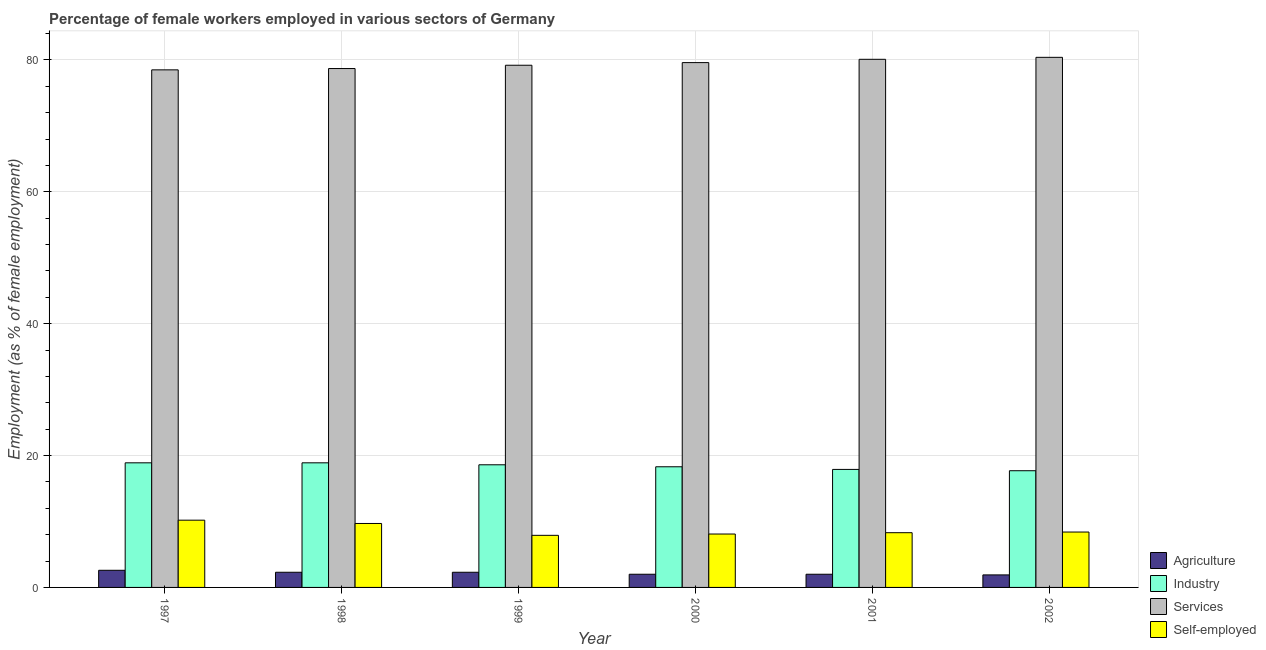How many groups of bars are there?
Provide a short and direct response. 6. Are the number of bars per tick equal to the number of legend labels?
Keep it short and to the point. Yes. Are the number of bars on each tick of the X-axis equal?
Make the answer very short. Yes. How many bars are there on the 1st tick from the right?
Ensure brevity in your answer.  4. What is the percentage of female workers in industry in 1999?
Provide a short and direct response. 18.6. Across all years, what is the maximum percentage of self employed female workers?
Provide a succinct answer. 10.2. Across all years, what is the minimum percentage of female workers in services?
Give a very brief answer. 78.5. In which year was the percentage of female workers in industry minimum?
Your answer should be very brief. 2002. What is the total percentage of female workers in industry in the graph?
Offer a terse response. 110.3. What is the difference between the percentage of self employed female workers in 1998 and that in 1999?
Provide a short and direct response. 1.8. What is the difference between the percentage of self employed female workers in 2002 and the percentage of female workers in industry in 1998?
Your answer should be compact. -1.3. What is the average percentage of female workers in industry per year?
Give a very brief answer. 18.38. What is the ratio of the percentage of female workers in agriculture in 1997 to that in 1998?
Provide a short and direct response. 1.13. Is the percentage of female workers in services in 1998 less than that in 1999?
Make the answer very short. Yes. What is the difference between the highest and the second highest percentage of female workers in agriculture?
Your answer should be compact. 0.3. What is the difference between the highest and the lowest percentage of female workers in services?
Offer a terse response. 1.9. Is the sum of the percentage of female workers in agriculture in 2000 and 2001 greater than the maximum percentage of female workers in services across all years?
Offer a terse response. Yes. Is it the case that in every year, the sum of the percentage of female workers in industry and percentage of female workers in agriculture is greater than the sum of percentage of self employed female workers and percentage of female workers in services?
Your answer should be very brief. No. What does the 4th bar from the left in 2002 represents?
Your answer should be compact. Self-employed. What does the 3rd bar from the right in 1997 represents?
Your answer should be compact. Industry. Is it the case that in every year, the sum of the percentage of female workers in agriculture and percentage of female workers in industry is greater than the percentage of female workers in services?
Offer a very short reply. No. How many bars are there?
Your answer should be very brief. 24. How many years are there in the graph?
Offer a terse response. 6. What is the difference between two consecutive major ticks on the Y-axis?
Keep it short and to the point. 20. Are the values on the major ticks of Y-axis written in scientific E-notation?
Make the answer very short. No. Where does the legend appear in the graph?
Provide a short and direct response. Bottom right. What is the title of the graph?
Your response must be concise. Percentage of female workers employed in various sectors of Germany. What is the label or title of the X-axis?
Make the answer very short. Year. What is the label or title of the Y-axis?
Ensure brevity in your answer.  Employment (as % of female employment). What is the Employment (as % of female employment) in Agriculture in 1997?
Keep it short and to the point. 2.6. What is the Employment (as % of female employment) of Industry in 1997?
Your answer should be very brief. 18.9. What is the Employment (as % of female employment) of Services in 1997?
Offer a terse response. 78.5. What is the Employment (as % of female employment) in Self-employed in 1997?
Your response must be concise. 10.2. What is the Employment (as % of female employment) in Agriculture in 1998?
Your answer should be compact. 2.3. What is the Employment (as % of female employment) in Industry in 1998?
Provide a succinct answer. 18.9. What is the Employment (as % of female employment) of Services in 1998?
Keep it short and to the point. 78.7. What is the Employment (as % of female employment) in Self-employed in 1998?
Keep it short and to the point. 9.7. What is the Employment (as % of female employment) of Agriculture in 1999?
Provide a short and direct response. 2.3. What is the Employment (as % of female employment) of Industry in 1999?
Provide a succinct answer. 18.6. What is the Employment (as % of female employment) in Services in 1999?
Provide a short and direct response. 79.2. What is the Employment (as % of female employment) in Self-employed in 1999?
Your answer should be compact. 7.9. What is the Employment (as % of female employment) in Industry in 2000?
Provide a succinct answer. 18.3. What is the Employment (as % of female employment) of Services in 2000?
Provide a succinct answer. 79.6. What is the Employment (as % of female employment) in Self-employed in 2000?
Offer a very short reply. 8.1. What is the Employment (as % of female employment) in Industry in 2001?
Offer a terse response. 17.9. What is the Employment (as % of female employment) in Services in 2001?
Provide a short and direct response. 80.1. What is the Employment (as % of female employment) of Self-employed in 2001?
Your answer should be very brief. 8.3. What is the Employment (as % of female employment) of Agriculture in 2002?
Offer a very short reply. 1.9. What is the Employment (as % of female employment) in Industry in 2002?
Provide a succinct answer. 17.7. What is the Employment (as % of female employment) of Services in 2002?
Provide a succinct answer. 80.4. What is the Employment (as % of female employment) in Self-employed in 2002?
Give a very brief answer. 8.4. Across all years, what is the maximum Employment (as % of female employment) in Agriculture?
Offer a terse response. 2.6. Across all years, what is the maximum Employment (as % of female employment) of Industry?
Ensure brevity in your answer.  18.9. Across all years, what is the maximum Employment (as % of female employment) of Services?
Your answer should be compact. 80.4. Across all years, what is the maximum Employment (as % of female employment) in Self-employed?
Give a very brief answer. 10.2. Across all years, what is the minimum Employment (as % of female employment) in Agriculture?
Your answer should be compact. 1.9. Across all years, what is the minimum Employment (as % of female employment) in Industry?
Keep it short and to the point. 17.7. Across all years, what is the minimum Employment (as % of female employment) of Services?
Offer a very short reply. 78.5. Across all years, what is the minimum Employment (as % of female employment) in Self-employed?
Provide a succinct answer. 7.9. What is the total Employment (as % of female employment) of Industry in the graph?
Your answer should be very brief. 110.3. What is the total Employment (as % of female employment) of Services in the graph?
Offer a very short reply. 476.5. What is the total Employment (as % of female employment) in Self-employed in the graph?
Your response must be concise. 52.6. What is the difference between the Employment (as % of female employment) of Industry in 1997 and that in 1998?
Keep it short and to the point. 0. What is the difference between the Employment (as % of female employment) of Self-employed in 1997 and that in 1998?
Give a very brief answer. 0.5. What is the difference between the Employment (as % of female employment) of Agriculture in 1997 and that in 1999?
Keep it short and to the point. 0.3. What is the difference between the Employment (as % of female employment) of Industry in 1997 and that in 1999?
Your answer should be compact. 0.3. What is the difference between the Employment (as % of female employment) in Services in 1997 and that in 1999?
Your answer should be compact. -0.7. What is the difference between the Employment (as % of female employment) in Self-employed in 1997 and that in 1999?
Make the answer very short. 2.3. What is the difference between the Employment (as % of female employment) in Agriculture in 1997 and that in 2000?
Your answer should be very brief. 0.6. What is the difference between the Employment (as % of female employment) in Industry in 1997 and that in 2000?
Provide a short and direct response. 0.6. What is the difference between the Employment (as % of female employment) in Services in 1997 and that in 2000?
Provide a succinct answer. -1.1. What is the difference between the Employment (as % of female employment) of Industry in 1997 and that in 2001?
Give a very brief answer. 1. What is the difference between the Employment (as % of female employment) of Self-employed in 1997 and that in 2001?
Make the answer very short. 1.9. What is the difference between the Employment (as % of female employment) in Industry in 1997 and that in 2002?
Give a very brief answer. 1.2. What is the difference between the Employment (as % of female employment) in Services in 1998 and that in 1999?
Provide a short and direct response. -0.5. What is the difference between the Employment (as % of female employment) in Self-employed in 1998 and that in 1999?
Your answer should be compact. 1.8. What is the difference between the Employment (as % of female employment) in Industry in 1998 and that in 2000?
Make the answer very short. 0.6. What is the difference between the Employment (as % of female employment) of Services in 1998 and that in 2000?
Your response must be concise. -0.9. What is the difference between the Employment (as % of female employment) in Self-employed in 1998 and that in 2000?
Your answer should be compact. 1.6. What is the difference between the Employment (as % of female employment) in Agriculture in 1998 and that in 2002?
Your answer should be very brief. 0.4. What is the difference between the Employment (as % of female employment) in Services in 1998 and that in 2002?
Make the answer very short. -1.7. What is the difference between the Employment (as % of female employment) in Self-employed in 1998 and that in 2002?
Your answer should be compact. 1.3. What is the difference between the Employment (as % of female employment) in Agriculture in 1999 and that in 2000?
Your answer should be very brief. 0.3. What is the difference between the Employment (as % of female employment) in Industry in 1999 and that in 2000?
Keep it short and to the point. 0.3. What is the difference between the Employment (as % of female employment) of Self-employed in 1999 and that in 2000?
Keep it short and to the point. -0.2. What is the difference between the Employment (as % of female employment) in Agriculture in 1999 and that in 2001?
Provide a succinct answer. 0.3. What is the difference between the Employment (as % of female employment) of Industry in 1999 and that in 2001?
Your answer should be compact. 0.7. What is the difference between the Employment (as % of female employment) of Self-employed in 1999 and that in 2001?
Ensure brevity in your answer.  -0.4. What is the difference between the Employment (as % of female employment) in Agriculture in 1999 and that in 2002?
Your answer should be very brief. 0.4. What is the difference between the Employment (as % of female employment) in Services in 1999 and that in 2002?
Provide a succinct answer. -1.2. What is the difference between the Employment (as % of female employment) in Self-employed in 1999 and that in 2002?
Provide a short and direct response. -0.5. What is the difference between the Employment (as % of female employment) in Services in 2000 and that in 2001?
Your response must be concise. -0.5. What is the difference between the Employment (as % of female employment) in Self-employed in 2000 and that in 2001?
Your response must be concise. -0.2. What is the difference between the Employment (as % of female employment) in Industry in 2000 and that in 2002?
Offer a terse response. 0.6. What is the difference between the Employment (as % of female employment) of Services in 2000 and that in 2002?
Offer a very short reply. -0.8. What is the difference between the Employment (as % of female employment) of Agriculture in 2001 and that in 2002?
Your answer should be compact. 0.1. What is the difference between the Employment (as % of female employment) in Industry in 2001 and that in 2002?
Your response must be concise. 0.2. What is the difference between the Employment (as % of female employment) of Services in 2001 and that in 2002?
Your response must be concise. -0.3. What is the difference between the Employment (as % of female employment) in Self-employed in 2001 and that in 2002?
Provide a short and direct response. -0.1. What is the difference between the Employment (as % of female employment) in Agriculture in 1997 and the Employment (as % of female employment) in Industry in 1998?
Provide a succinct answer. -16.3. What is the difference between the Employment (as % of female employment) in Agriculture in 1997 and the Employment (as % of female employment) in Services in 1998?
Offer a terse response. -76.1. What is the difference between the Employment (as % of female employment) in Agriculture in 1997 and the Employment (as % of female employment) in Self-employed in 1998?
Your answer should be compact. -7.1. What is the difference between the Employment (as % of female employment) in Industry in 1997 and the Employment (as % of female employment) in Services in 1998?
Provide a short and direct response. -59.8. What is the difference between the Employment (as % of female employment) of Industry in 1997 and the Employment (as % of female employment) of Self-employed in 1998?
Give a very brief answer. 9.2. What is the difference between the Employment (as % of female employment) of Services in 1997 and the Employment (as % of female employment) of Self-employed in 1998?
Your response must be concise. 68.8. What is the difference between the Employment (as % of female employment) of Agriculture in 1997 and the Employment (as % of female employment) of Services in 1999?
Your answer should be compact. -76.6. What is the difference between the Employment (as % of female employment) of Agriculture in 1997 and the Employment (as % of female employment) of Self-employed in 1999?
Keep it short and to the point. -5.3. What is the difference between the Employment (as % of female employment) of Industry in 1997 and the Employment (as % of female employment) of Services in 1999?
Keep it short and to the point. -60.3. What is the difference between the Employment (as % of female employment) in Industry in 1997 and the Employment (as % of female employment) in Self-employed in 1999?
Provide a short and direct response. 11. What is the difference between the Employment (as % of female employment) in Services in 1997 and the Employment (as % of female employment) in Self-employed in 1999?
Make the answer very short. 70.6. What is the difference between the Employment (as % of female employment) of Agriculture in 1997 and the Employment (as % of female employment) of Industry in 2000?
Provide a short and direct response. -15.7. What is the difference between the Employment (as % of female employment) of Agriculture in 1997 and the Employment (as % of female employment) of Services in 2000?
Provide a short and direct response. -77. What is the difference between the Employment (as % of female employment) in Agriculture in 1997 and the Employment (as % of female employment) in Self-employed in 2000?
Make the answer very short. -5.5. What is the difference between the Employment (as % of female employment) of Industry in 1997 and the Employment (as % of female employment) of Services in 2000?
Make the answer very short. -60.7. What is the difference between the Employment (as % of female employment) in Industry in 1997 and the Employment (as % of female employment) in Self-employed in 2000?
Give a very brief answer. 10.8. What is the difference between the Employment (as % of female employment) of Services in 1997 and the Employment (as % of female employment) of Self-employed in 2000?
Keep it short and to the point. 70.4. What is the difference between the Employment (as % of female employment) in Agriculture in 1997 and the Employment (as % of female employment) in Industry in 2001?
Provide a short and direct response. -15.3. What is the difference between the Employment (as % of female employment) in Agriculture in 1997 and the Employment (as % of female employment) in Services in 2001?
Make the answer very short. -77.5. What is the difference between the Employment (as % of female employment) of Industry in 1997 and the Employment (as % of female employment) of Services in 2001?
Give a very brief answer. -61.2. What is the difference between the Employment (as % of female employment) of Industry in 1997 and the Employment (as % of female employment) of Self-employed in 2001?
Provide a succinct answer. 10.6. What is the difference between the Employment (as % of female employment) of Services in 1997 and the Employment (as % of female employment) of Self-employed in 2001?
Give a very brief answer. 70.2. What is the difference between the Employment (as % of female employment) in Agriculture in 1997 and the Employment (as % of female employment) in Industry in 2002?
Give a very brief answer. -15.1. What is the difference between the Employment (as % of female employment) in Agriculture in 1997 and the Employment (as % of female employment) in Services in 2002?
Your answer should be compact. -77.8. What is the difference between the Employment (as % of female employment) in Industry in 1997 and the Employment (as % of female employment) in Services in 2002?
Your response must be concise. -61.5. What is the difference between the Employment (as % of female employment) in Industry in 1997 and the Employment (as % of female employment) in Self-employed in 2002?
Provide a succinct answer. 10.5. What is the difference between the Employment (as % of female employment) of Services in 1997 and the Employment (as % of female employment) of Self-employed in 2002?
Make the answer very short. 70.1. What is the difference between the Employment (as % of female employment) of Agriculture in 1998 and the Employment (as % of female employment) of Industry in 1999?
Your answer should be compact. -16.3. What is the difference between the Employment (as % of female employment) of Agriculture in 1998 and the Employment (as % of female employment) of Services in 1999?
Offer a terse response. -76.9. What is the difference between the Employment (as % of female employment) in Industry in 1998 and the Employment (as % of female employment) in Services in 1999?
Provide a short and direct response. -60.3. What is the difference between the Employment (as % of female employment) of Industry in 1998 and the Employment (as % of female employment) of Self-employed in 1999?
Offer a terse response. 11. What is the difference between the Employment (as % of female employment) of Services in 1998 and the Employment (as % of female employment) of Self-employed in 1999?
Provide a succinct answer. 70.8. What is the difference between the Employment (as % of female employment) in Agriculture in 1998 and the Employment (as % of female employment) in Industry in 2000?
Keep it short and to the point. -16. What is the difference between the Employment (as % of female employment) of Agriculture in 1998 and the Employment (as % of female employment) of Services in 2000?
Provide a short and direct response. -77.3. What is the difference between the Employment (as % of female employment) of Industry in 1998 and the Employment (as % of female employment) of Services in 2000?
Ensure brevity in your answer.  -60.7. What is the difference between the Employment (as % of female employment) of Services in 1998 and the Employment (as % of female employment) of Self-employed in 2000?
Give a very brief answer. 70.6. What is the difference between the Employment (as % of female employment) in Agriculture in 1998 and the Employment (as % of female employment) in Industry in 2001?
Provide a short and direct response. -15.6. What is the difference between the Employment (as % of female employment) in Agriculture in 1998 and the Employment (as % of female employment) in Services in 2001?
Offer a terse response. -77.8. What is the difference between the Employment (as % of female employment) of Industry in 1998 and the Employment (as % of female employment) of Services in 2001?
Ensure brevity in your answer.  -61.2. What is the difference between the Employment (as % of female employment) of Services in 1998 and the Employment (as % of female employment) of Self-employed in 2001?
Your response must be concise. 70.4. What is the difference between the Employment (as % of female employment) in Agriculture in 1998 and the Employment (as % of female employment) in Industry in 2002?
Offer a very short reply. -15.4. What is the difference between the Employment (as % of female employment) in Agriculture in 1998 and the Employment (as % of female employment) in Services in 2002?
Your answer should be very brief. -78.1. What is the difference between the Employment (as % of female employment) of Industry in 1998 and the Employment (as % of female employment) of Services in 2002?
Make the answer very short. -61.5. What is the difference between the Employment (as % of female employment) in Industry in 1998 and the Employment (as % of female employment) in Self-employed in 2002?
Give a very brief answer. 10.5. What is the difference between the Employment (as % of female employment) of Services in 1998 and the Employment (as % of female employment) of Self-employed in 2002?
Your response must be concise. 70.3. What is the difference between the Employment (as % of female employment) of Agriculture in 1999 and the Employment (as % of female employment) of Industry in 2000?
Keep it short and to the point. -16. What is the difference between the Employment (as % of female employment) in Agriculture in 1999 and the Employment (as % of female employment) in Services in 2000?
Keep it short and to the point. -77.3. What is the difference between the Employment (as % of female employment) of Agriculture in 1999 and the Employment (as % of female employment) of Self-employed in 2000?
Your answer should be compact. -5.8. What is the difference between the Employment (as % of female employment) in Industry in 1999 and the Employment (as % of female employment) in Services in 2000?
Ensure brevity in your answer.  -61. What is the difference between the Employment (as % of female employment) of Services in 1999 and the Employment (as % of female employment) of Self-employed in 2000?
Ensure brevity in your answer.  71.1. What is the difference between the Employment (as % of female employment) in Agriculture in 1999 and the Employment (as % of female employment) in Industry in 2001?
Your response must be concise. -15.6. What is the difference between the Employment (as % of female employment) of Agriculture in 1999 and the Employment (as % of female employment) of Services in 2001?
Offer a very short reply. -77.8. What is the difference between the Employment (as % of female employment) in Industry in 1999 and the Employment (as % of female employment) in Services in 2001?
Ensure brevity in your answer.  -61.5. What is the difference between the Employment (as % of female employment) in Industry in 1999 and the Employment (as % of female employment) in Self-employed in 2001?
Your response must be concise. 10.3. What is the difference between the Employment (as % of female employment) in Services in 1999 and the Employment (as % of female employment) in Self-employed in 2001?
Provide a short and direct response. 70.9. What is the difference between the Employment (as % of female employment) of Agriculture in 1999 and the Employment (as % of female employment) of Industry in 2002?
Your answer should be compact. -15.4. What is the difference between the Employment (as % of female employment) in Agriculture in 1999 and the Employment (as % of female employment) in Services in 2002?
Give a very brief answer. -78.1. What is the difference between the Employment (as % of female employment) in Industry in 1999 and the Employment (as % of female employment) in Services in 2002?
Make the answer very short. -61.8. What is the difference between the Employment (as % of female employment) in Services in 1999 and the Employment (as % of female employment) in Self-employed in 2002?
Provide a short and direct response. 70.8. What is the difference between the Employment (as % of female employment) of Agriculture in 2000 and the Employment (as % of female employment) of Industry in 2001?
Your answer should be compact. -15.9. What is the difference between the Employment (as % of female employment) of Agriculture in 2000 and the Employment (as % of female employment) of Services in 2001?
Make the answer very short. -78.1. What is the difference between the Employment (as % of female employment) in Agriculture in 2000 and the Employment (as % of female employment) in Self-employed in 2001?
Offer a terse response. -6.3. What is the difference between the Employment (as % of female employment) in Industry in 2000 and the Employment (as % of female employment) in Services in 2001?
Provide a short and direct response. -61.8. What is the difference between the Employment (as % of female employment) in Industry in 2000 and the Employment (as % of female employment) in Self-employed in 2001?
Provide a succinct answer. 10. What is the difference between the Employment (as % of female employment) of Services in 2000 and the Employment (as % of female employment) of Self-employed in 2001?
Offer a very short reply. 71.3. What is the difference between the Employment (as % of female employment) in Agriculture in 2000 and the Employment (as % of female employment) in Industry in 2002?
Your answer should be very brief. -15.7. What is the difference between the Employment (as % of female employment) of Agriculture in 2000 and the Employment (as % of female employment) of Services in 2002?
Your answer should be compact. -78.4. What is the difference between the Employment (as % of female employment) in Agriculture in 2000 and the Employment (as % of female employment) in Self-employed in 2002?
Ensure brevity in your answer.  -6.4. What is the difference between the Employment (as % of female employment) of Industry in 2000 and the Employment (as % of female employment) of Services in 2002?
Your answer should be compact. -62.1. What is the difference between the Employment (as % of female employment) of Industry in 2000 and the Employment (as % of female employment) of Self-employed in 2002?
Offer a terse response. 9.9. What is the difference between the Employment (as % of female employment) of Services in 2000 and the Employment (as % of female employment) of Self-employed in 2002?
Provide a succinct answer. 71.2. What is the difference between the Employment (as % of female employment) in Agriculture in 2001 and the Employment (as % of female employment) in Industry in 2002?
Offer a very short reply. -15.7. What is the difference between the Employment (as % of female employment) of Agriculture in 2001 and the Employment (as % of female employment) of Services in 2002?
Your answer should be compact. -78.4. What is the difference between the Employment (as % of female employment) of Industry in 2001 and the Employment (as % of female employment) of Services in 2002?
Provide a short and direct response. -62.5. What is the difference between the Employment (as % of female employment) of Services in 2001 and the Employment (as % of female employment) of Self-employed in 2002?
Provide a short and direct response. 71.7. What is the average Employment (as % of female employment) of Agriculture per year?
Make the answer very short. 2.18. What is the average Employment (as % of female employment) in Industry per year?
Provide a short and direct response. 18.38. What is the average Employment (as % of female employment) in Services per year?
Ensure brevity in your answer.  79.42. What is the average Employment (as % of female employment) in Self-employed per year?
Your response must be concise. 8.77. In the year 1997, what is the difference between the Employment (as % of female employment) in Agriculture and Employment (as % of female employment) in Industry?
Give a very brief answer. -16.3. In the year 1997, what is the difference between the Employment (as % of female employment) of Agriculture and Employment (as % of female employment) of Services?
Keep it short and to the point. -75.9. In the year 1997, what is the difference between the Employment (as % of female employment) in Agriculture and Employment (as % of female employment) in Self-employed?
Your answer should be very brief. -7.6. In the year 1997, what is the difference between the Employment (as % of female employment) in Industry and Employment (as % of female employment) in Services?
Your answer should be very brief. -59.6. In the year 1997, what is the difference between the Employment (as % of female employment) in Services and Employment (as % of female employment) in Self-employed?
Your answer should be compact. 68.3. In the year 1998, what is the difference between the Employment (as % of female employment) in Agriculture and Employment (as % of female employment) in Industry?
Your response must be concise. -16.6. In the year 1998, what is the difference between the Employment (as % of female employment) of Agriculture and Employment (as % of female employment) of Services?
Your answer should be very brief. -76.4. In the year 1998, what is the difference between the Employment (as % of female employment) of Industry and Employment (as % of female employment) of Services?
Make the answer very short. -59.8. In the year 1998, what is the difference between the Employment (as % of female employment) of Services and Employment (as % of female employment) of Self-employed?
Offer a very short reply. 69. In the year 1999, what is the difference between the Employment (as % of female employment) of Agriculture and Employment (as % of female employment) of Industry?
Ensure brevity in your answer.  -16.3. In the year 1999, what is the difference between the Employment (as % of female employment) in Agriculture and Employment (as % of female employment) in Services?
Provide a short and direct response. -76.9. In the year 1999, what is the difference between the Employment (as % of female employment) of Agriculture and Employment (as % of female employment) of Self-employed?
Your answer should be very brief. -5.6. In the year 1999, what is the difference between the Employment (as % of female employment) of Industry and Employment (as % of female employment) of Services?
Ensure brevity in your answer.  -60.6. In the year 1999, what is the difference between the Employment (as % of female employment) of Industry and Employment (as % of female employment) of Self-employed?
Your answer should be compact. 10.7. In the year 1999, what is the difference between the Employment (as % of female employment) of Services and Employment (as % of female employment) of Self-employed?
Keep it short and to the point. 71.3. In the year 2000, what is the difference between the Employment (as % of female employment) of Agriculture and Employment (as % of female employment) of Industry?
Offer a very short reply. -16.3. In the year 2000, what is the difference between the Employment (as % of female employment) in Agriculture and Employment (as % of female employment) in Services?
Your answer should be compact. -77.6. In the year 2000, what is the difference between the Employment (as % of female employment) of Agriculture and Employment (as % of female employment) of Self-employed?
Offer a very short reply. -6.1. In the year 2000, what is the difference between the Employment (as % of female employment) in Industry and Employment (as % of female employment) in Services?
Make the answer very short. -61.3. In the year 2000, what is the difference between the Employment (as % of female employment) of Services and Employment (as % of female employment) of Self-employed?
Offer a very short reply. 71.5. In the year 2001, what is the difference between the Employment (as % of female employment) of Agriculture and Employment (as % of female employment) of Industry?
Provide a short and direct response. -15.9. In the year 2001, what is the difference between the Employment (as % of female employment) in Agriculture and Employment (as % of female employment) in Services?
Provide a succinct answer. -78.1. In the year 2001, what is the difference between the Employment (as % of female employment) in Agriculture and Employment (as % of female employment) in Self-employed?
Ensure brevity in your answer.  -6.3. In the year 2001, what is the difference between the Employment (as % of female employment) of Industry and Employment (as % of female employment) of Services?
Offer a terse response. -62.2. In the year 2001, what is the difference between the Employment (as % of female employment) of Services and Employment (as % of female employment) of Self-employed?
Your answer should be very brief. 71.8. In the year 2002, what is the difference between the Employment (as % of female employment) of Agriculture and Employment (as % of female employment) of Industry?
Your answer should be very brief. -15.8. In the year 2002, what is the difference between the Employment (as % of female employment) of Agriculture and Employment (as % of female employment) of Services?
Ensure brevity in your answer.  -78.5. In the year 2002, what is the difference between the Employment (as % of female employment) of Industry and Employment (as % of female employment) of Services?
Keep it short and to the point. -62.7. In the year 2002, what is the difference between the Employment (as % of female employment) of Industry and Employment (as % of female employment) of Self-employed?
Offer a terse response. 9.3. In the year 2002, what is the difference between the Employment (as % of female employment) in Services and Employment (as % of female employment) in Self-employed?
Offer a very short reply. 72. What is the ratio of the Employment (as % of female employment) in Agriculture in 1997 to that in 1998?
Your answer should be very brief. 1.13. What is the ratio of the Employment (as % of female employment) of Services in 1997 to that in 1998?
Your answer should be compact. 1. What is the ratio of the Employment (as % of female employment) of Self-employed in 1997 to that in 1998?
Give a very brief answer. 1.05. What is the ratio of the Employment (as % of female employment) of Agriculture in 1997 to that in 1999?
Make the answer very short. 1.13. What is the ratio of the Employment (as % of female employment) of Industry in 1997 to that in 1999?
Offer a terse response. 1.02. What is the ratio of the Employment (as % of female employment) in Services in 1997 to that in 1999?
Your answer should be compact. 0.99. What is the ratio of the Employment (as % of female employment) of Self-employed in 1997 to that in 1999?
Your answer should be very brief. 1.29. What is the ratio of the Employment (as % of female employment) in Industry in 1997 to that in 2000?
Provide a succinct answer. 1.03. What is the ratio of the Employment (as % of female employment) in Services in 1997 to that in 2000?
Give a very brief answer. 0.99. What is the ratio of the Employment (as % of female employment) of Self-employed in 1997 to that in 2000?
Your answer should be very brief. 1.26. What is the ratio of the Employment (as % of female employment) of Industry in 1997 to that in 2001?
Your answer should be very brief. 1.06. What is the ratio of the Employment (as % of female employment) of Self-employed in 1997 to that in 2001?
Give a very brief answer. 1.23. What is the ratio of the Employment (as % of female employment) in Agriculture in 1997 to that in 2002?
Offer a very short reply. 1.37. What is the ratio of the Employment (as % of female employment) of Industry in 1997 to that in 2002?
Make the answer very short. 1.07. What is the ratio of the Employment (as % of female employment) of Services in 1997 to that in 2002?
Offer a terse response. 0.98. What is the ratio of the Employment (as % of female employment) of Self-employed in 1997 to that in 2002?
Keep it short and to the point. 1.21. What is the ratio of the Employment (as % of female employment) in Industry in 1998 to that in 1999?
Ensure brevity in your answer.  1.02. What is the ratio of the Employment (as % of female employment) in Services in 1998 to that in 1999?
Make the answer very short. 0.99. What is the ratio of the Employment (as % of female employment) in Self-employed in 1998 to that in 1999?
Provide a short and direct response. 1.23. What is the ratio of the Employment (as % of female employment) in Agriculture in 1998 to that in 2000?
Your response must be concise. 1.15. What is the ratio of the Employment (as % of female employment) in Industry in 1998 to that in 2000?
Keep it short and to the point. 1.03. What is the ratio of the Employment (as % of female employment) of Services in 1998 to that in 2000?
Provide a succinct answer. 0.99. What is the ratio of the Employment (as % of female employment) of Self-employed in 1998 to that in 2000?
Offer a terse response. 1.2. What is the ratio of the Employment (as % of female employment) of Agriculture in 1998 to that in 2001?
Provide a succinct answer. 1.15. What is the ratio of the Employment (as % of female employment) in Industry in 1998 to that in 2001?
Offer a very short reply. 1.06. What is the ratio of the Employment (as % of female employment) in Services in 1998 to that in 2001?
Make the answer very short. 0.98. What is the ratio of the Employment (as % of female employment) of Self-employed in 1998 to that in 2001?
Keep it short and to the point. 1.17. What is the ratio of the Employment (as % of female employment) in Agriculture in 1998 to that in 2002?
Your answer should be very brief. 1.21. What is the ratio of the Employment (as % of female employment) in Industry in 1998 to that in 2002?
Your response must be concise. 1.07. What is the ratio of the Employment (as % of female employment) in Services in 1998 to that in 2002?
Your response must be concise. 0.98. What is the ratio of the Employment (as % of female employment) in Self-employed in 1998 to that in 2002?
Offer a very short reply. 1.15. What is the ratio of the Employment (as % of female employment) in Agriculture in 1999 to that in 2000?
Make the answer very short. 1.15. What is the ratio of the Employment (as % of female employment) of Industry in 1999 to that in 2000?
Your answer should be compact. 1.02. What is the ratio of the Employment (as % of female employment) of Self-employed in 1999 to that in 2000?
Your response must be concise. 0.98. What is the ratio of the Employment (as % of female employment) of Agriculture in 1999 to that in 2001?
Make the answer very short. 1.15. What is the ratio of the Employment (as % of female employment) of Industry in 1999 to that in 2001?
Your answer should be compact. 1.04. What is the ratio of the Employment (as % of female employment) of Self-employed in 1999 to that in 2001?
Your response must be concise. 0.95. What is the ratio of the Employment (as % of female employment) of Agriculture in 1999 to that in 2002?
Your answer should be compact. 1.21. What is the ratio of the Employment (as % of female employment) of Industry in 1999 to that in 2002?
Provide a succinct answer. 1.05. What is the ratio of the Employment (as % of female employment) in Services in 1999 to that in 2002?
Keep it short and to the point. 0.99. What is the ratio of the Employment (as % of female employment) of Self-employed in 1999 to that in 2002?
Keep it short and to the point. 0.94. What is the ratio of the Employment (as % of female employment) of Industry in 2000 to that in 2001?
Ensure brevity in your answer.  1.02. What is the ratio of the Employment (as % of female employment) in Services in 2000 to that in 2001?
Your answer should be compact. 0.99. What is the ratio of the Employment (as % of female employment) in Self-employed in 2000 to that in 2001?
Your answer should be compact. 0.98. What is the ratio of the Employment (as % of female employment) in Agriculture in 2000 to that in 2002?
Offer a very short reply. 1.05. What is the ratio of the Employment (as % of female employment) of Industry in 2000 to that in 2002?
Make the answer very short. 1.03. What is the ratio of the Employment (as % of female employment) in Services in 2000 to that in 2002?
Your answer should be compact. 0.99. What is the ratio of the Employment (as % of female employment) in Self-employed in 2000 to that in 2002?
Your answer should be compact. 0.96. What is the ratio of the Employment (as % of female employment) in Agriculture in 2001 to that in 2002?
Provide a succinct answer. 1.05. What is the ratio of the Employment (as % of female employment) of Industry in 2001 to that in 2002?
Keep it short and to the point. 1.01. What is the difference between the highest and the second highest Employment (as % of female employment) in Agriculture?
Your answer should be very brief. 0.3. What is the difference between the highest and the second highest Employment (as % of female employment) in Self-employed?
Your answer should be compact. 0.5. What is the difference between the highest and the lowest Employment (as % of female employment) of Agriculture?
Your answer should be very brief. 0.7. What is the difference between the highest and the lowest Employment (as % of female employment) in Self-employed?
Give a very brief answer. 2.3. 